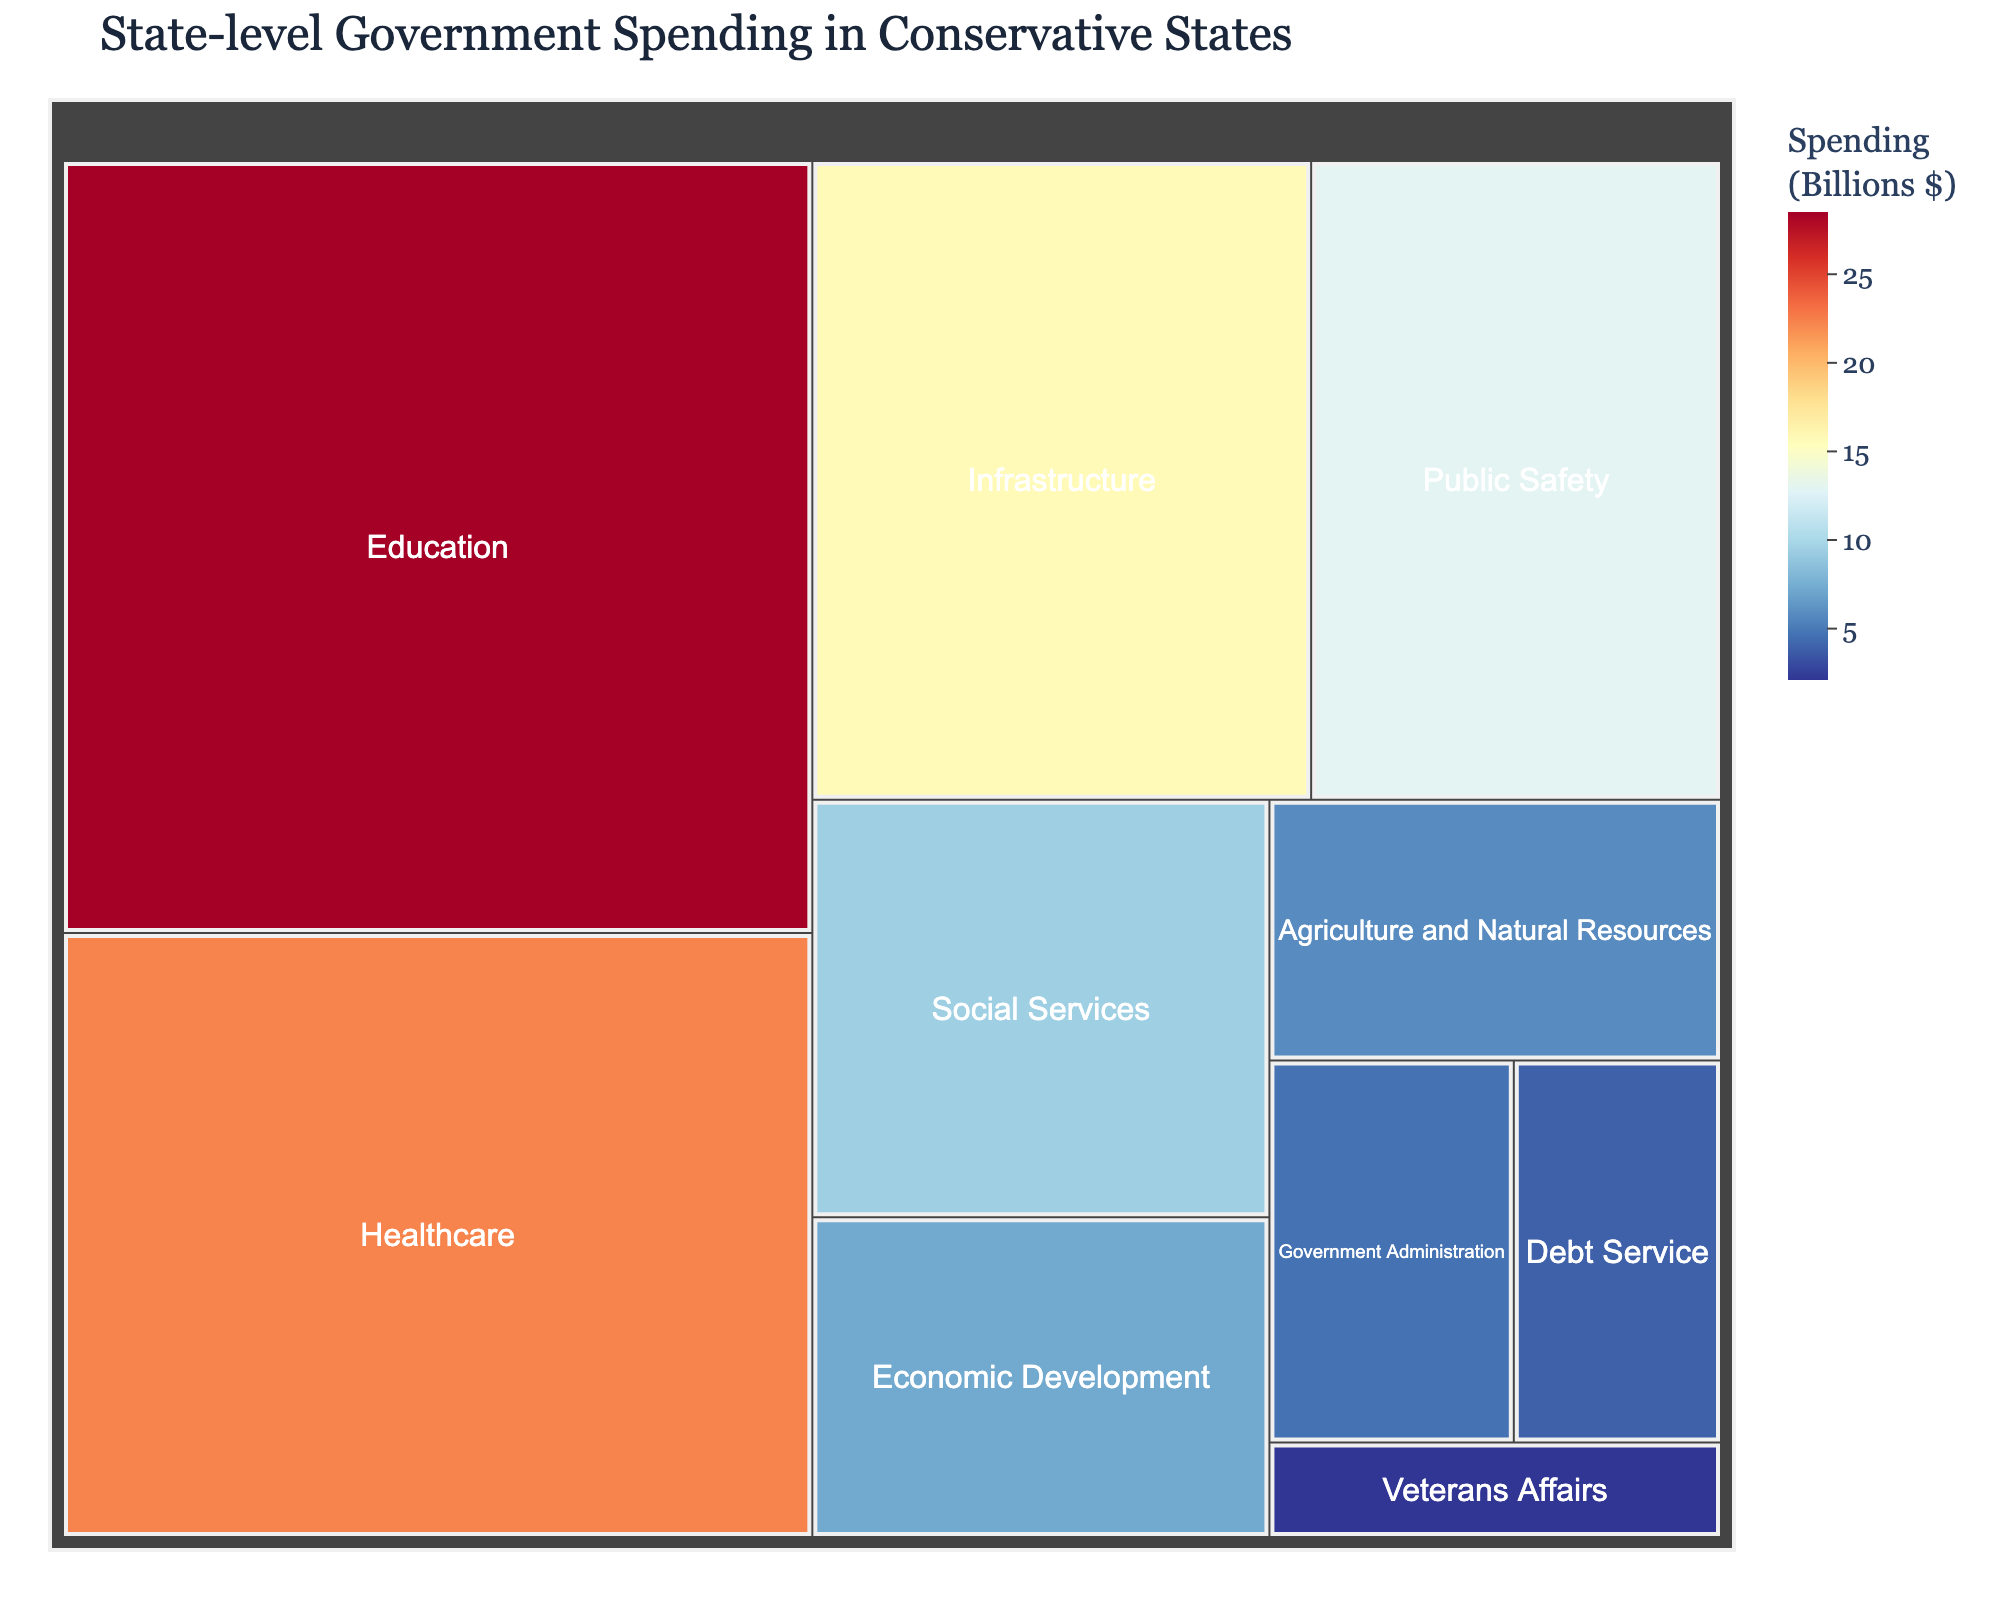What is the title of the treemap? The title is located at the top of the treemap and is usually designed to give a clear and concise idea of what the plot represents.
Answer: State-level Government Spending in Conservative States Which sector has the highest government spending? Look for the largest area in the treemap and the corresponding label, which represents the sector with the highest spending.
Answer: Education How much is spent on Healthcare? Find the area labeled "Healthcare" on the treemap and check the spending amount displayed in that section.
Answer: 22.3 Billion How does the spending on Infrastructure compare to Economic Development? Identify both "Infrastructure" and "Economic Development" in the treemap. Compare their spending values, noting that Infrastructure has a higher value.
Answer: Infrastructure has higher spending What is the combined spending on Public Safety and Social Services? Locate "Public Safety" and "Social Services" in the treemap. Add their spending amounts: 12.9 Billion (Public Safety) + 9.4 Billion (Social Services).
Answer: 22.3 Billion Which sector has the smallest allocation of spending? Find the smallest section in the treemap, which represents the sector with the lowest spending.
Answer: Veterans Affairs What is the difference in spending between Government Administration and Debt Service? Locate "Government Administration" and "Debt Service" sections. Subtract the spending of Debt Service from Government Administration: 4.6 Billion - 3.9 Billion.
Answer: 0.7 Billion Rank the sectors in descending order of spending. By examining the treemap, list the sectors from the highest to the lowest spending values: Education, Healthcare, Infrastructure, Public Safety, Social Services, Economic Development, Agriculture and Natural Resources, Government Administration, Debt Service, Veterans Affairs.
Answer: Education, Healthcare, Infrastructure, Public Safety, Social Services, Economic Development, Agriculture and Natural Resources, Government Administration, Debt Service, Veterans Affairs What proportion of the total spending is allocated to Agriculture and Natural Resources? Calculate the total spending by summing all sectors. Then, divide the spending for Agriculture and Natural Resources by this total and multiply by 100 to find the percentage. (28.5 + 22.3 + 15.7 + 12.9 + 9.4 + 7.2 + 5.8 + 4.6 + 3.9 + 2.1) = 112.4 Billion. Proportion = (5.8 / 112.4) * 100.
Answer: 5.2% Do the combined allocations for Education and Healthcare exceed 50% of total spending? Calculate the total spending and sum the spending for Education and Healthcare. Compare this sum to half of the total spending. (28.5 + 22.3) = 50.8. Total spending = 112.4. Half of total spending = 56.2.
Answer: No 